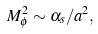Convert formula to latex. <formula><loc_0><loc_0><loc_500><loc_500>M ^ { 2 } _ { \phi } \sim \alpha _ { s } / a ^ { 2 } ,</formula> 